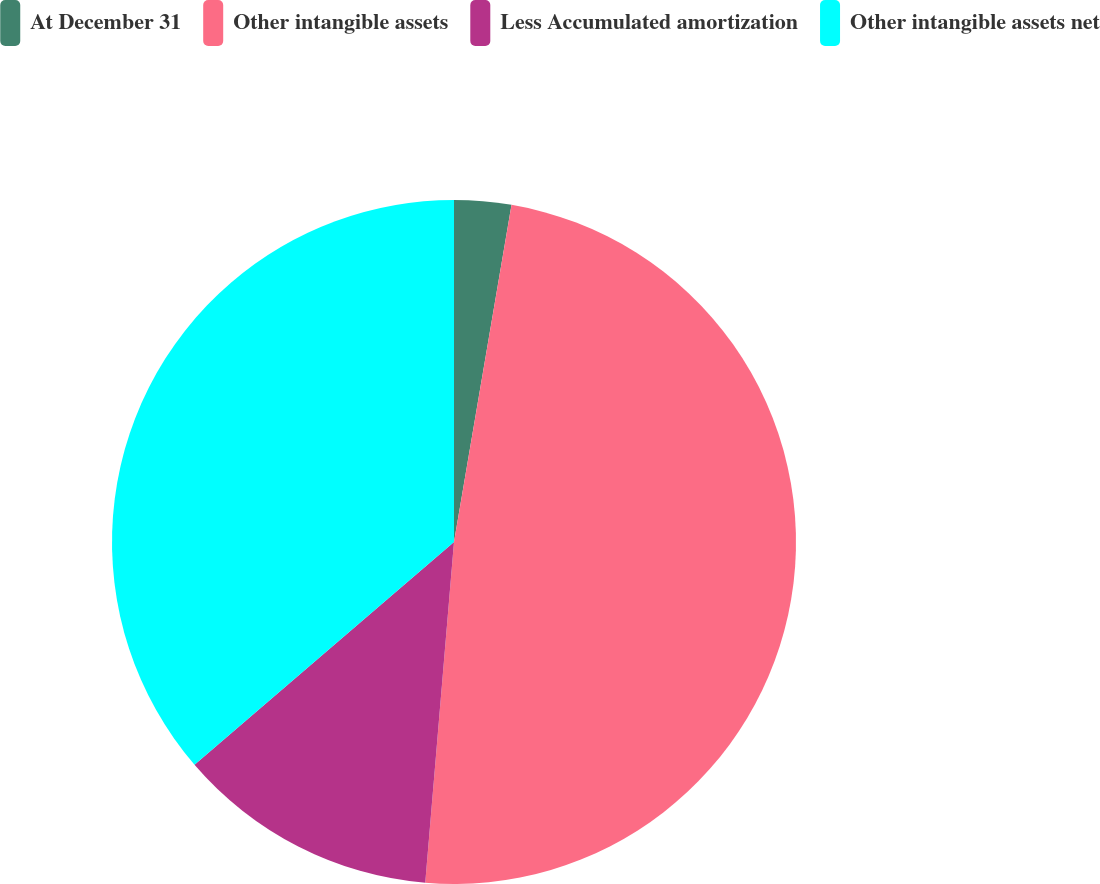Convert chart to OTSL. <chart><loc_0><loc_0><loc_500><loc_500><pie_chart><fcel>At December 31<fcel>Other intangible assets<fcel>Less Accumulated amortization<fcel>Other intangible assets net<nl><fcel>2.69%<fcel>48.65%<fcel>12.37%<fcel>36.29%<nl></chart> 